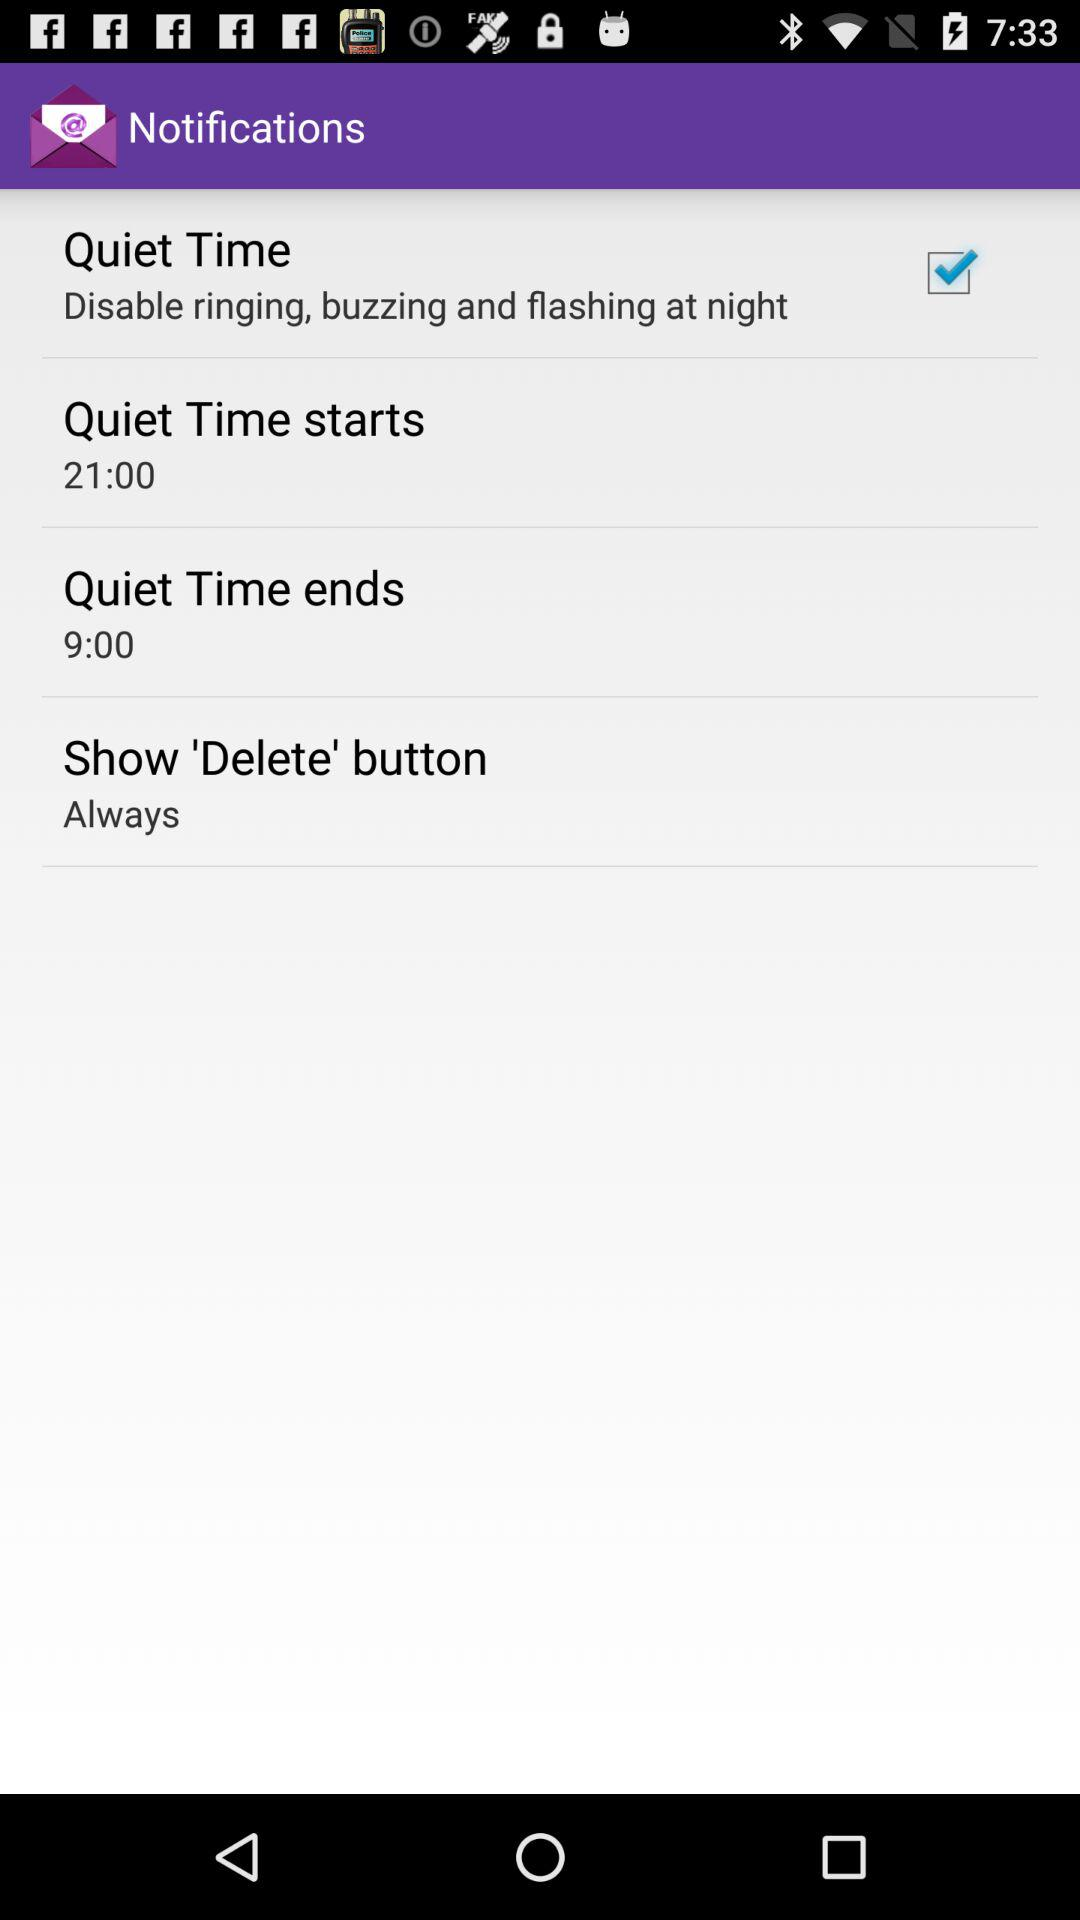What's the setting for "Show 'Delete' button"? The setting is "Always". 